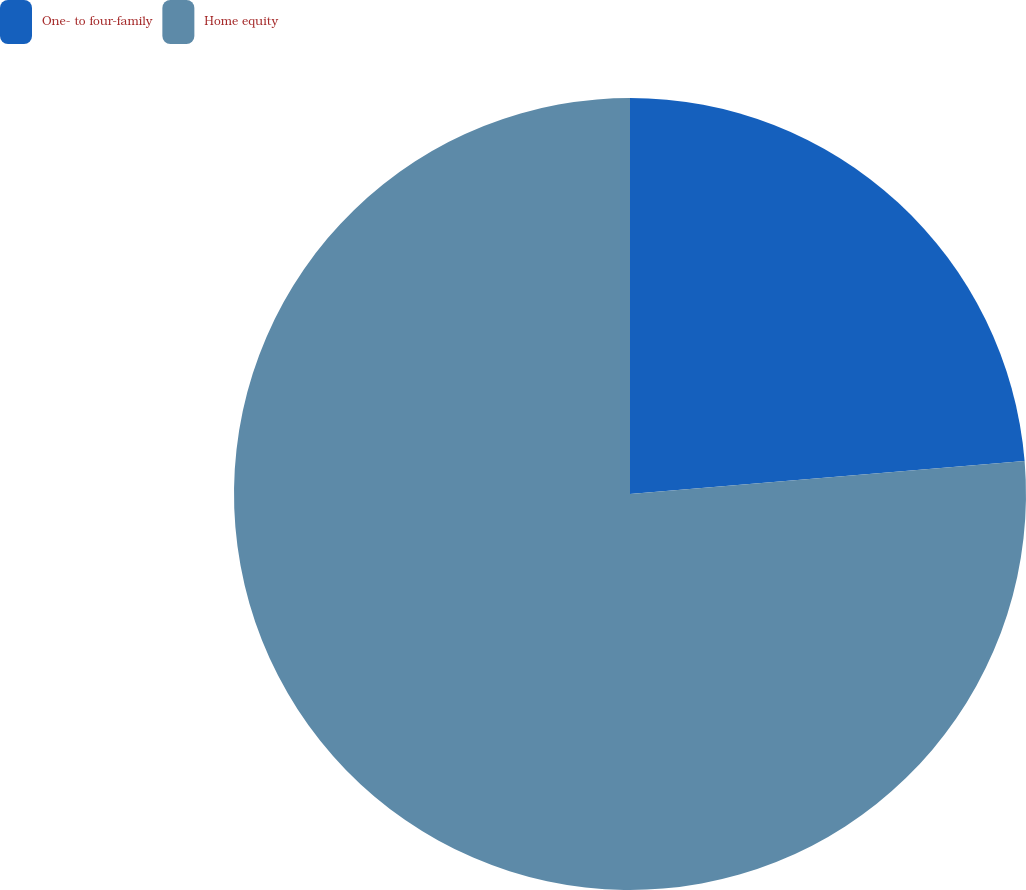Convert chart. <chart><loc_0><loc_0><loc_500><loc_500><pie_chart><fcel>One- to four-family<fcel>Home equity<nl><fcel>23.67%<fcel>76.33%<nl></chart> 